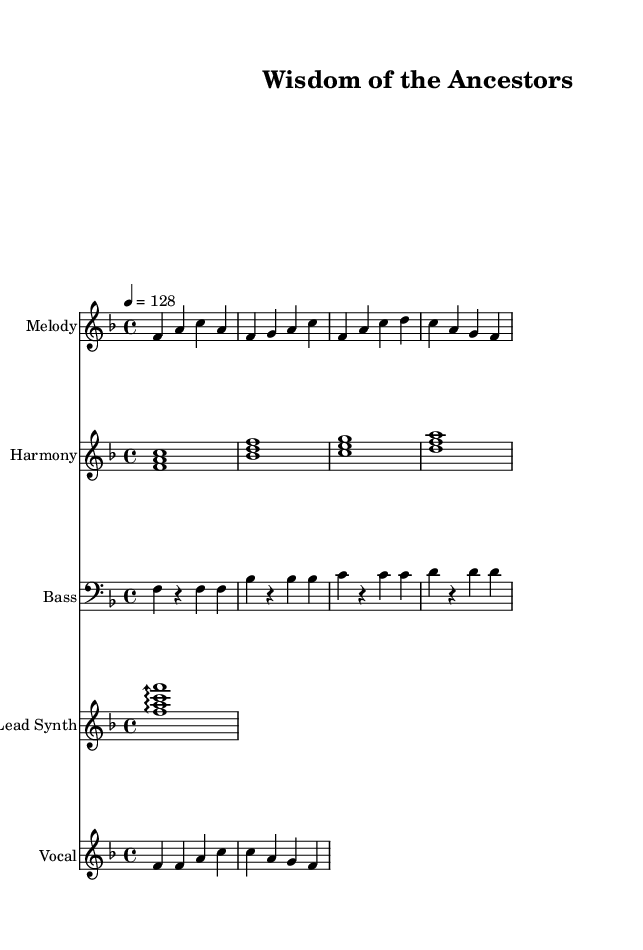What is the key signature of this music? The key signature is indicated at the beginning of the staff. It shows one flat, which corresponds to F major.
Answer: F major What is the time signature of the music? The time signature appears right after the key signature, represented by two numbers, where four is the top number, indicating beats per measure, and four is the bottom number, indicating the note value of each beat. It reads 4/4.
Answer: 4/4 What is the tempo marking for this piece? The tempo marking is located directly above the first measure and indicates how fast the music should be played. It states that the tempo is 128 beats per minute.
Answer: 128 How many measures does the melody section contain? By counting the individual groups of notes separated by vertical lines in the melody section, we can see there are four complete measures.
Answer: Four Which instrument plays the bass part? The specific staff labeled with "Bass" indicates that the bass line is played by a bass instrument, typically either an upright bass or electric bass.
Answer: Bass What type of music is this piece categorized as? The overall vibe created by the tempo, the structure of the melody with repetitive elements, and the synthesis sounds points toward a genre that is associated with electronic music and dance, specifically House music.
Answer: House What is the first lyric line sung in the vocal part? The vocal section showcases lyrics correlated to the notes, and the first line clearly reads "Wisdom flows like a river."
Answer: Wisdom flows like a river 